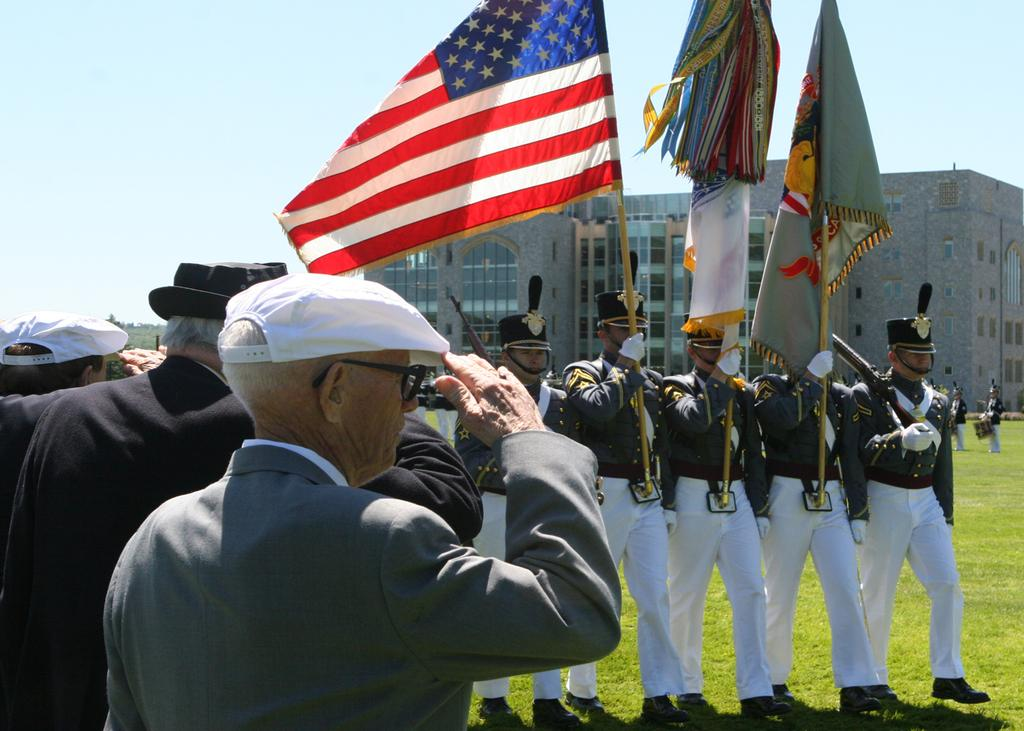What are the people in the image doing? The people in the image are standing. What are some of the people holding? Some of the people are holding flags. What can be seen in the background of the image? There is a building and the sky visible in the background of the image. What type of recess can be seen in the image? There is no recess present in the image. How does the snow affect the people in the image? There is no snow present in the image. 